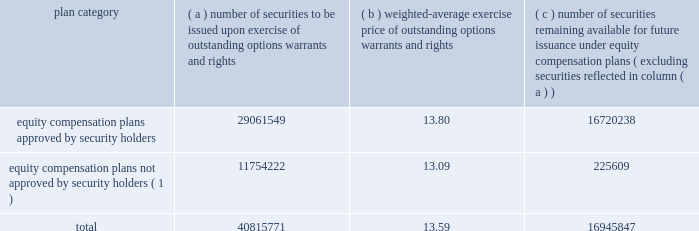( d ) securities authorized for issuance under equity compensation plans .
Except for the information concerning equity compensation plans below , the information required by item 12 is incorporated by reference to the company 2019s 2004 proxy statement under the caption 2018 2018security ownership of certain beneficial owners and management . 2019 2019 the table provides information about shares of aes common stock that may be issued under aes 2019s equity compensation plans , as of december 31 , 2003 : securities authorized for issuance under equity compensation plans ( as of december 31 , 2003 ) ( a ) ( b ) ( c ) number of securities remaining available for number of securities future issuance under to be issued upon weighted-average equity compensation exercise of exercise price plans ( excluding outstanding options , of outstanding options , securities reflected plan category warrants and rights warrants and rights in column ( a ) ) equity compensation plans approved by security holders .
29061549 13.80 16720238 equity compensation plans not approved by security holders ( 1 ) .
11754222 13.09 225609 .
( 1 ) the aes corporation 2001 non-officer stock option plan ( the 2018 2018plan 2019 2019 ) was adopted by our board of directors on october 18 , 2001 .
This plan did not require approval under either the sec or nyse rules and/or regulations .
Eligible participants under the plan include all of our non-officer employees .
As of the end of december 31 , 2003 , approximately 13500 employees held options under the plan .
The exercise price of each option awarded under the plan is equal to the fair market value of our common stock on the grant date of the option .
Options under the plan generally vest as to 50% ( 50 % ) of their underlying shares on each anniversary of the option grant date , however , grants dated october 25 , 2001 vest in one year .
The plan shall expire on october 25 , 2011 .
The board may amend , modify or terminate the plan at any time .
Item 13 .
Certain relationships and related transactions see the information contained under the caption 2018 2018related party transactions 2019 2019 of the proxy statement for the annual meeting of stockholders of the registrant to be held on april 28 , 2004 , which information is incorporated herein by reference .
Item 14 .
Principal accounting fees and services the information required by this item will be contained in our proxy statement for the annual meeting of shareholders to be held on april 28 , 2004 and is hereby incorporated by reference. .
At the end of 2003 , what would total proceeds be for the company if all remaining shares in the plan were exercised? 
Computations: (40815771 * 13.59)
Answer: 554686327.89. ( d ) securities authorized for issuance under equity compensation plans .
Except for the information concerning equity compensation plans below , the information required by item 12 is incorporated by reference to the company 2019s 2004 proxy statement under the caption 2018 2018security ownership of certain beneficial owners and management . 2019 2019 the table provides information about shares of aes common stock that may be issued under aes 2019s equity compensation plans , as of december 31 , 2003 : securities authorized for issuance under equity compensation plans ( as of december 31 , 2003 ) ( a ) ( b ) ( c ) number of securities remaining available for number of securities future issuance under to be issued upon weighted-average equity compensation exercise of exercise price plans ( excluding outstanding options , of outstanding options , securities reflected plan category warrants and rights warrants and rights in column ( a ) ) equity compensation plans approved by security holders .
29061549 13.80 16720238 equity compensation plans not approved by security holders ( 1 ) .
11754222 13.09 225609 .
( 1 ) the aes corporation 2001 non-officer stock option plan ( the 2018 2018plan 2019 2019 ) was adopted by our board of directors on october 18 , 2001 .
This plan did not require approval under either the sec or nyse rules and/or regulations .
Eligible participants under the plan include all of our non-officer employees .
As of the end of december 31 , 2003 , approximately 13500 employees held options under the plan .
The exercise price of each option awarded under the plan is equal to the fair market value of our common stock on the grant date of the option .
Options under the plan generally vest as to 50% ( 50 % ) of their underlying shares on each anniversary of the option grant date , however , grants dated october 25 , 2001 vest in one year .
The plan shall expire on october 25 , 2011 .
The board may amend , modify or terminate the plan at any time .
Item 13 .
Certain relationships and related transactions see the information contained under the caption 2018 2018related party transactions 2019 2019 of the proxy statement for the annual meeting of stockholders of the registrant to be held on april 28 , 2004 , which information is incorporated herein by reference .
Item 14 .
Principal accounting fees and services the information required by this item will be contained in our proxy statement for the annual meeting of shareholders to be held on april 28 , 2004 and is hereby incorporated by reference. .
For the outstanding options warrants and rights , what percentage of these securities to be issued was from approved plans? 
Computations: (11754222 / 40815771)
Answer: 0.28798. 